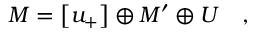Convert formula to latex. <formula><loc_0><loc_0><loc_500><loc_500>M = \left [ u _ { + } \right ] \oplus M ^ { \prime } \oplus U \quad ,</formula> 